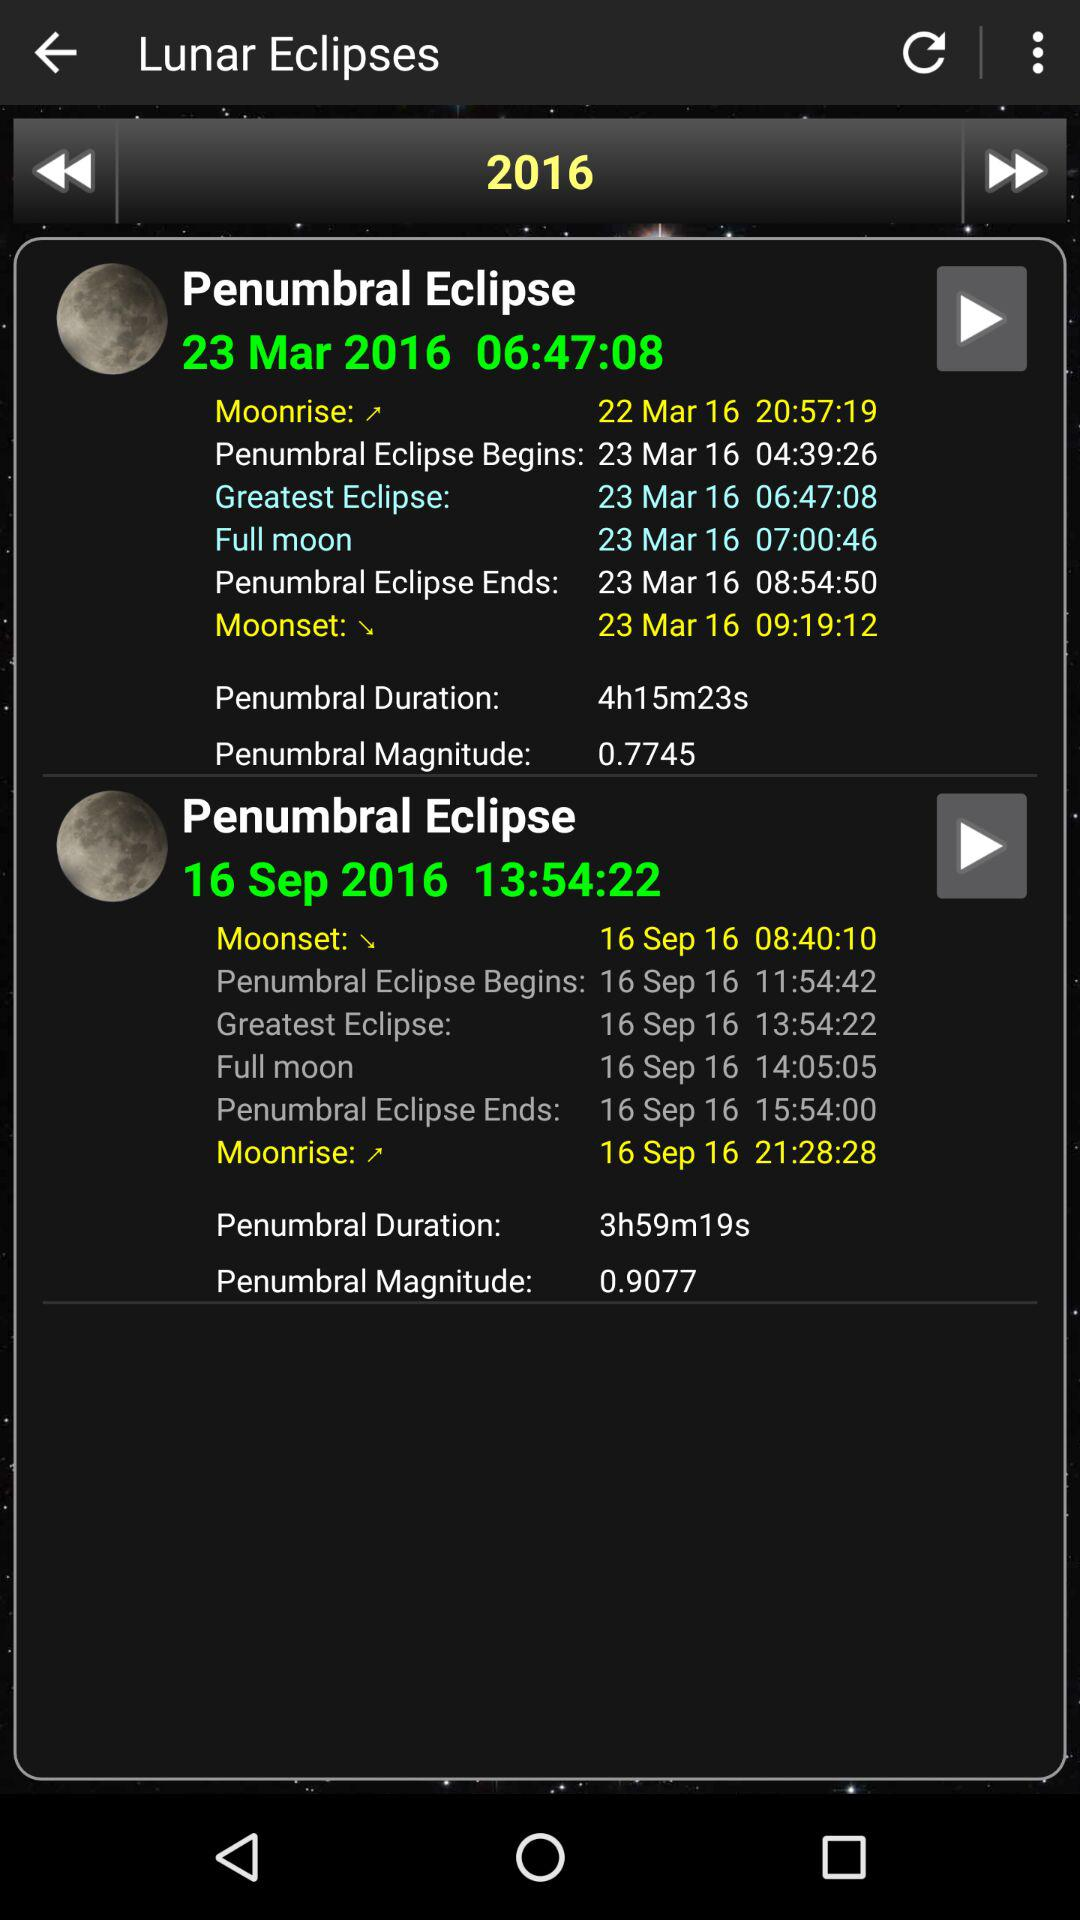In what year is data on lunar eclipses given? The year is 2016. 